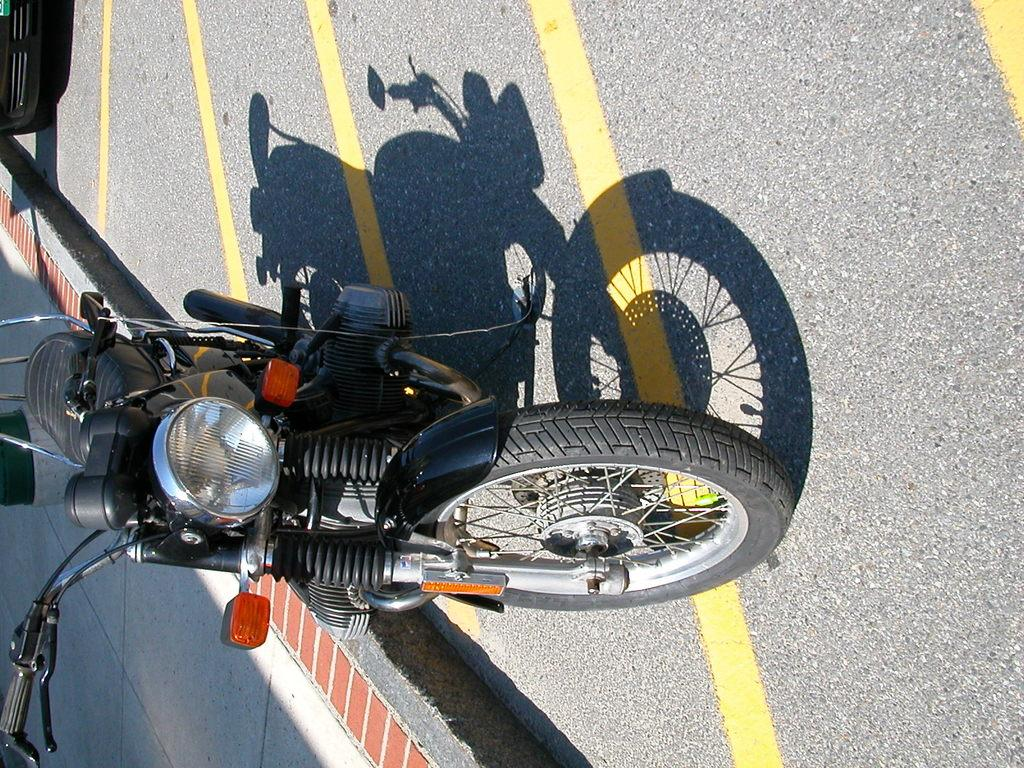What is the main subject of the image? The main subject of the image is a motorbike. Where is the motorbike located? The motorbike is on a road. What is the temper of the authority figure in the image? There is no authority figure present in the image, so it is not possible to determine their temper. 